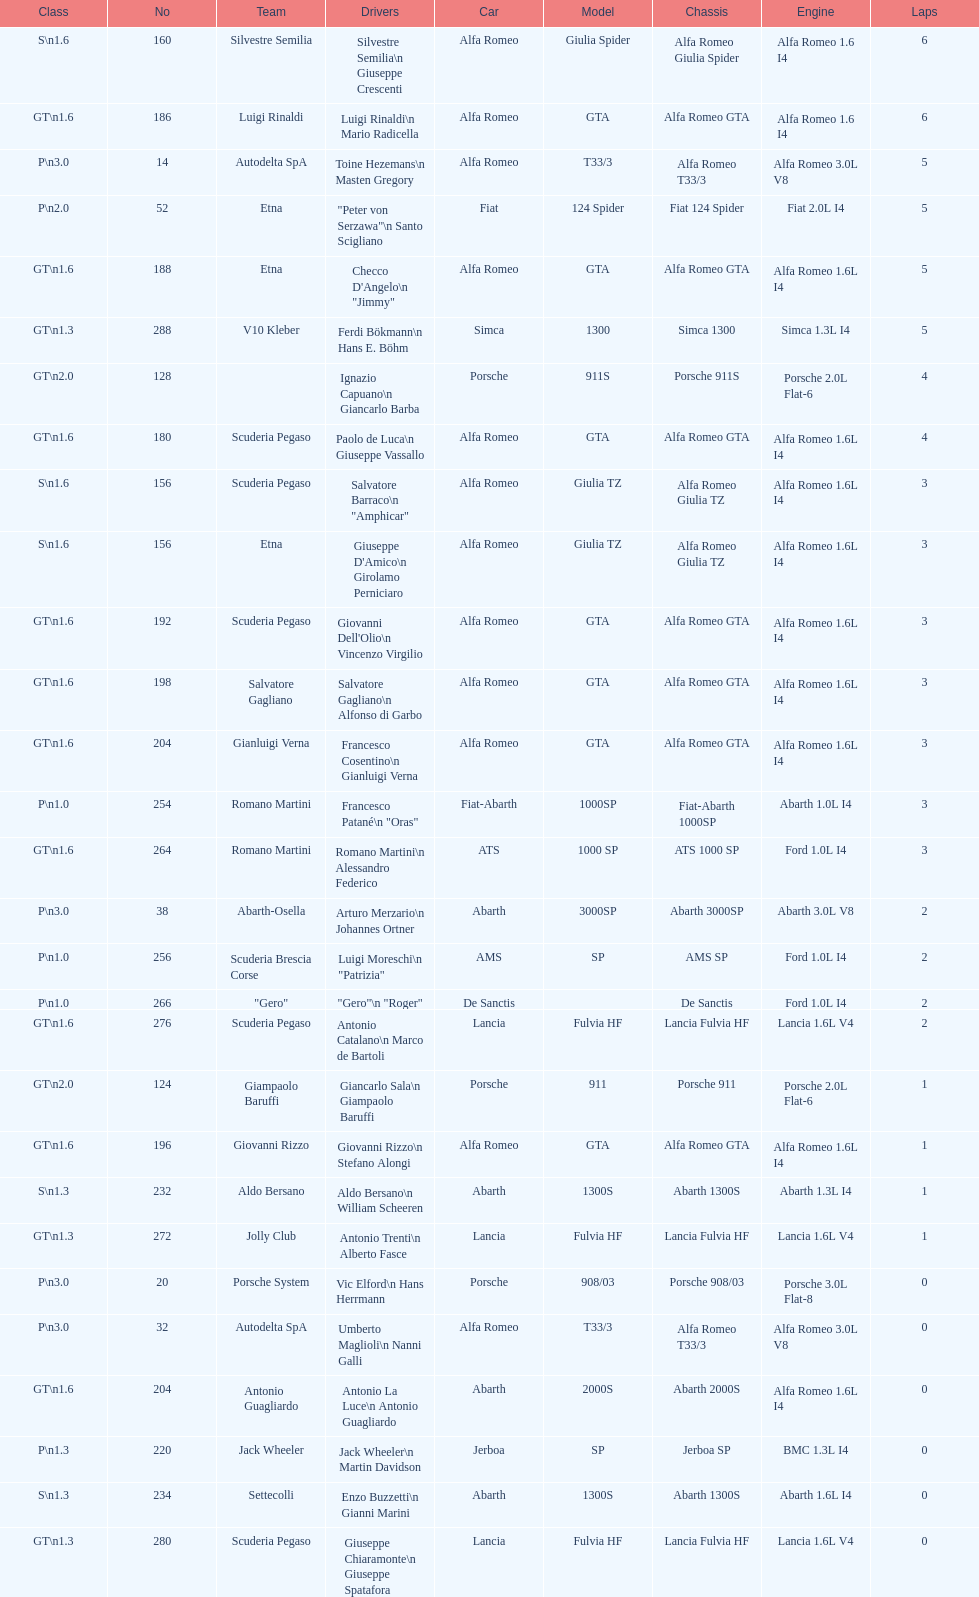What class is below s 1.6? GT 1.6. 